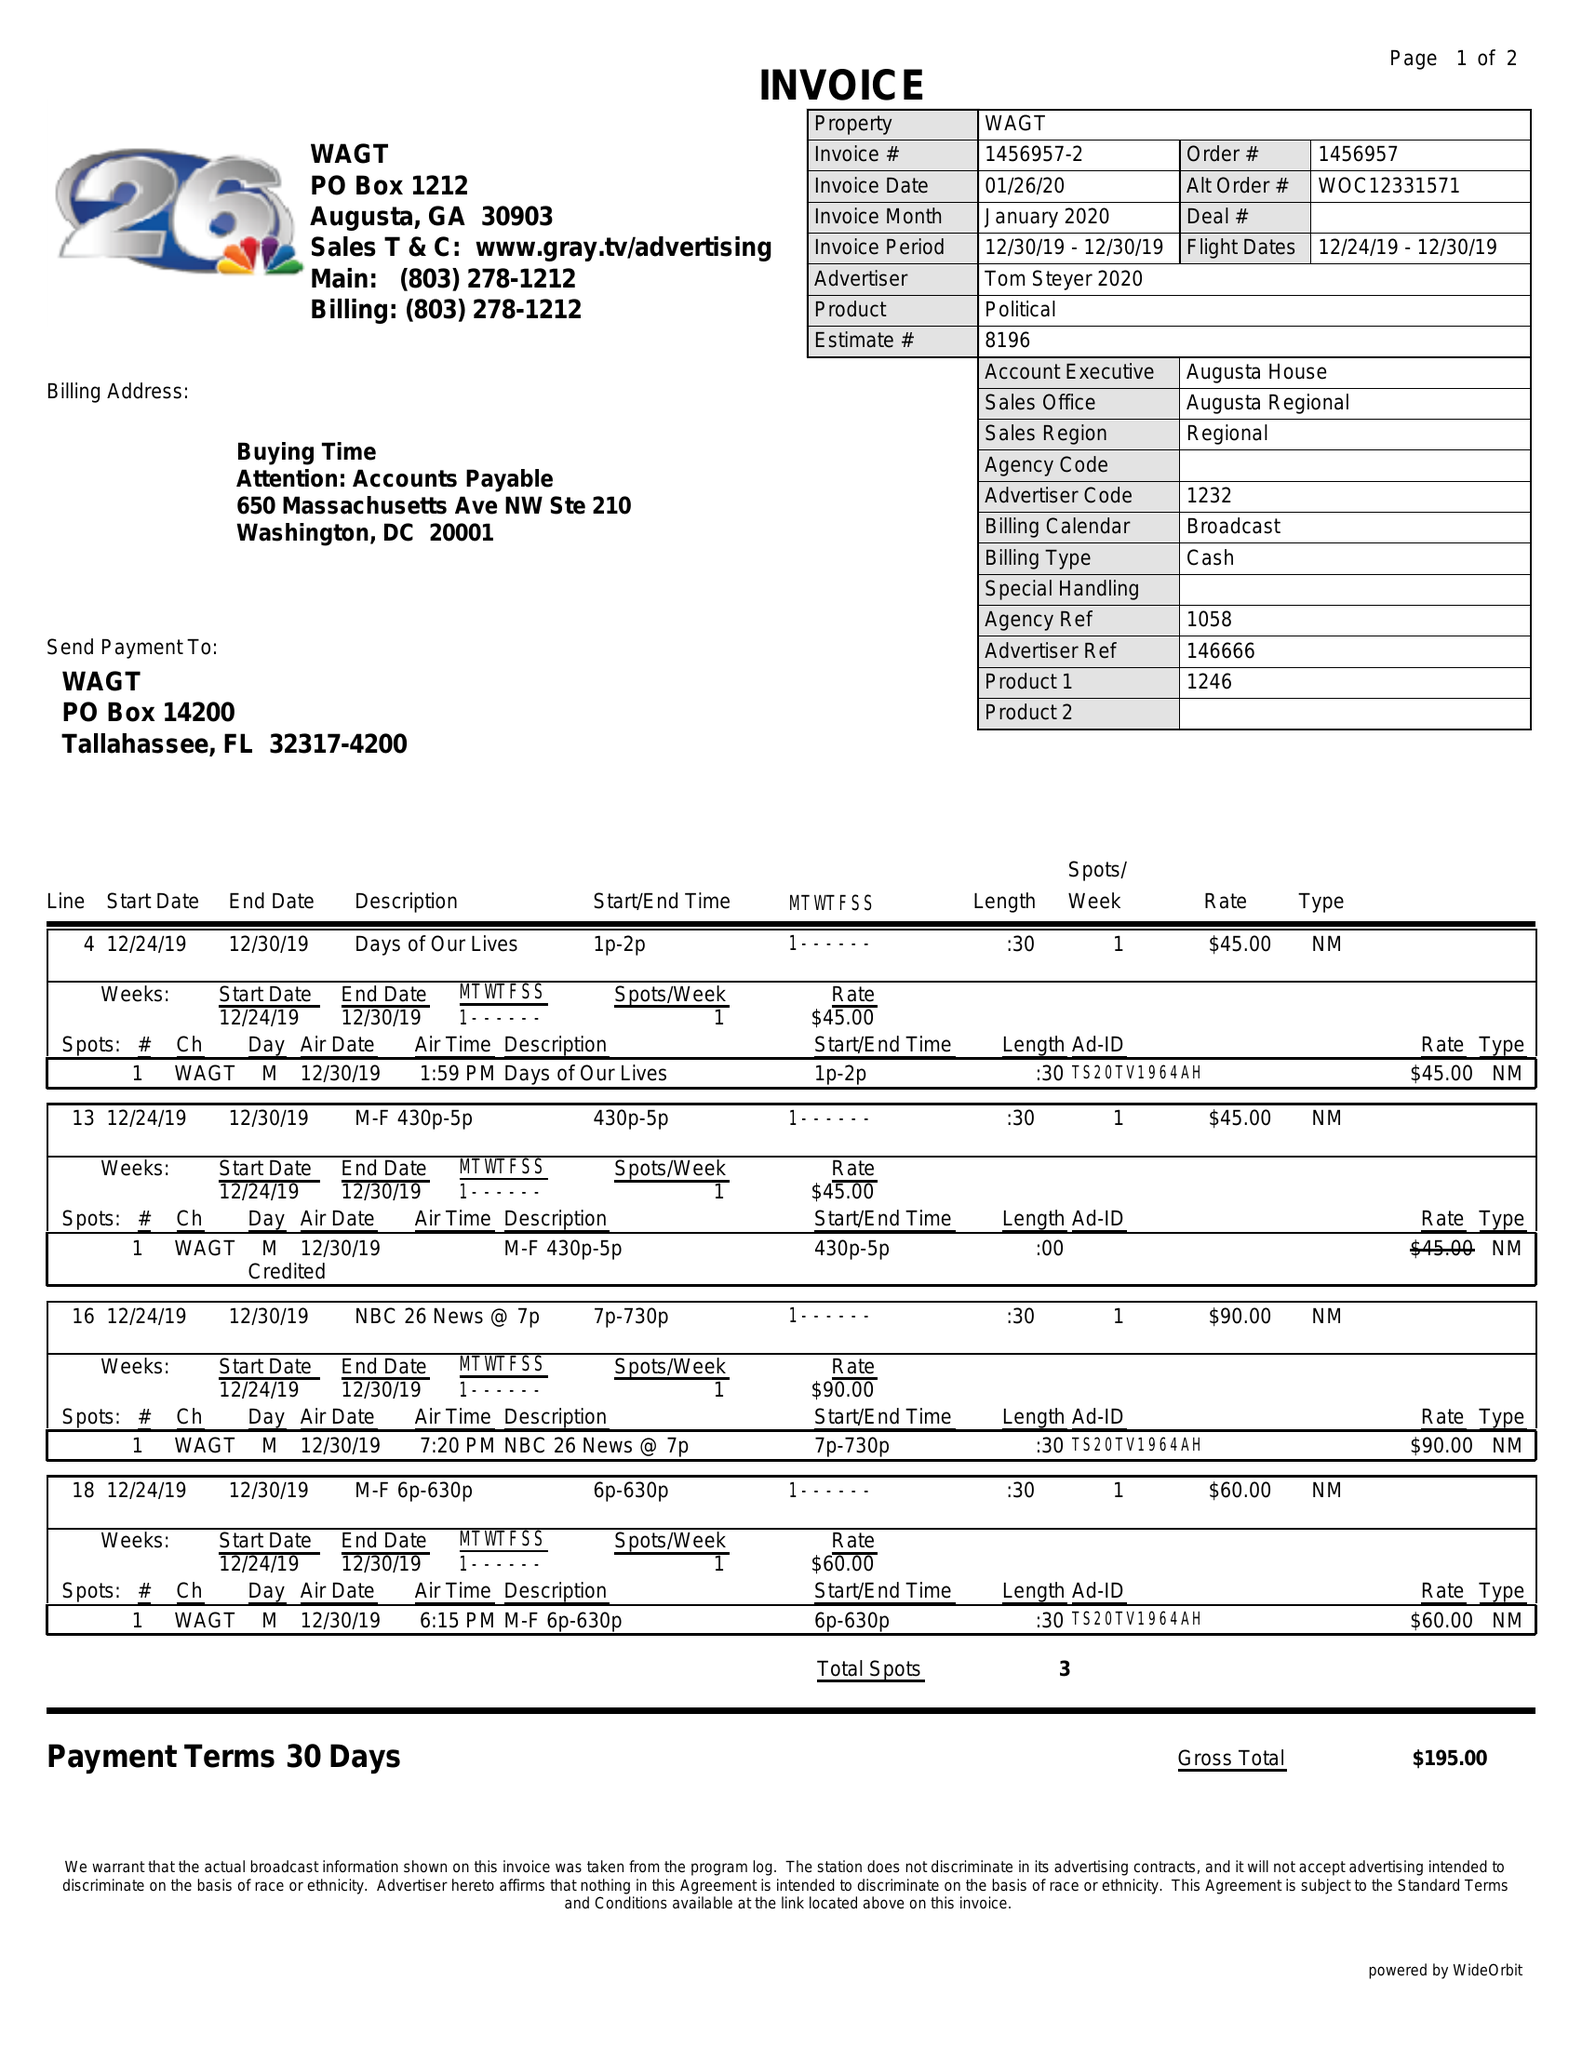What is the value for the flight_from?
Answer the question using a single word or phrase. 12/24/19 